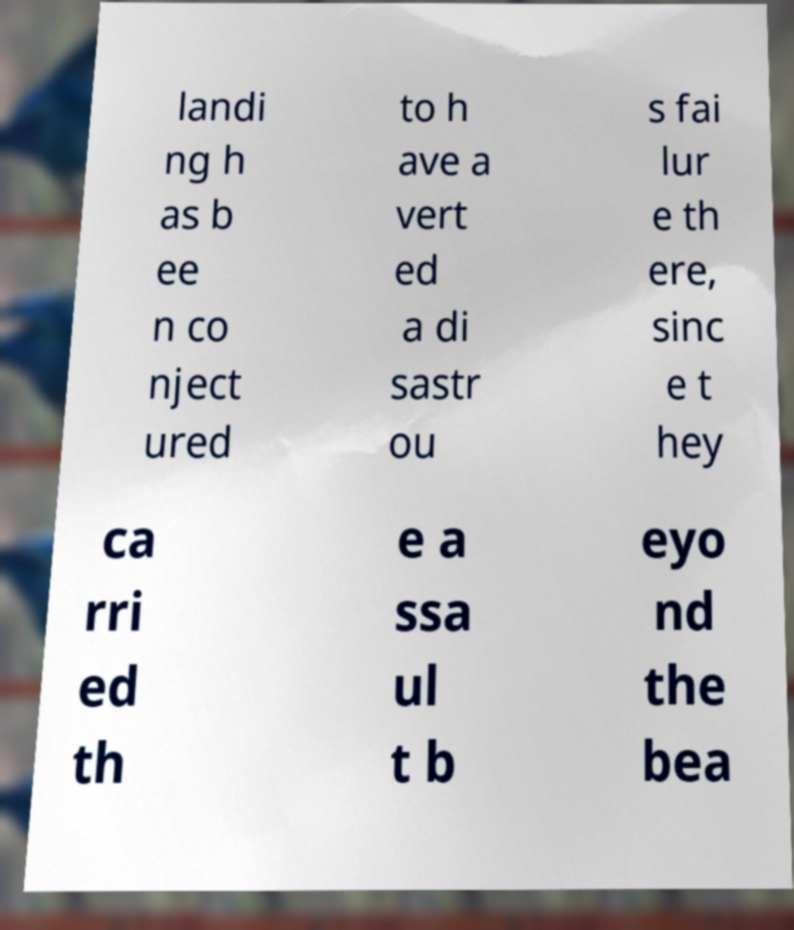Could you assist in decoding the text presented in this image and type it out clearly? landi ng h as b ee n co nject ured to h ave a vert ed a di sastr ou s fai lur e th ere, sinc e t hey ca rri ed th e a ssa ul t b eyo nd the bea 